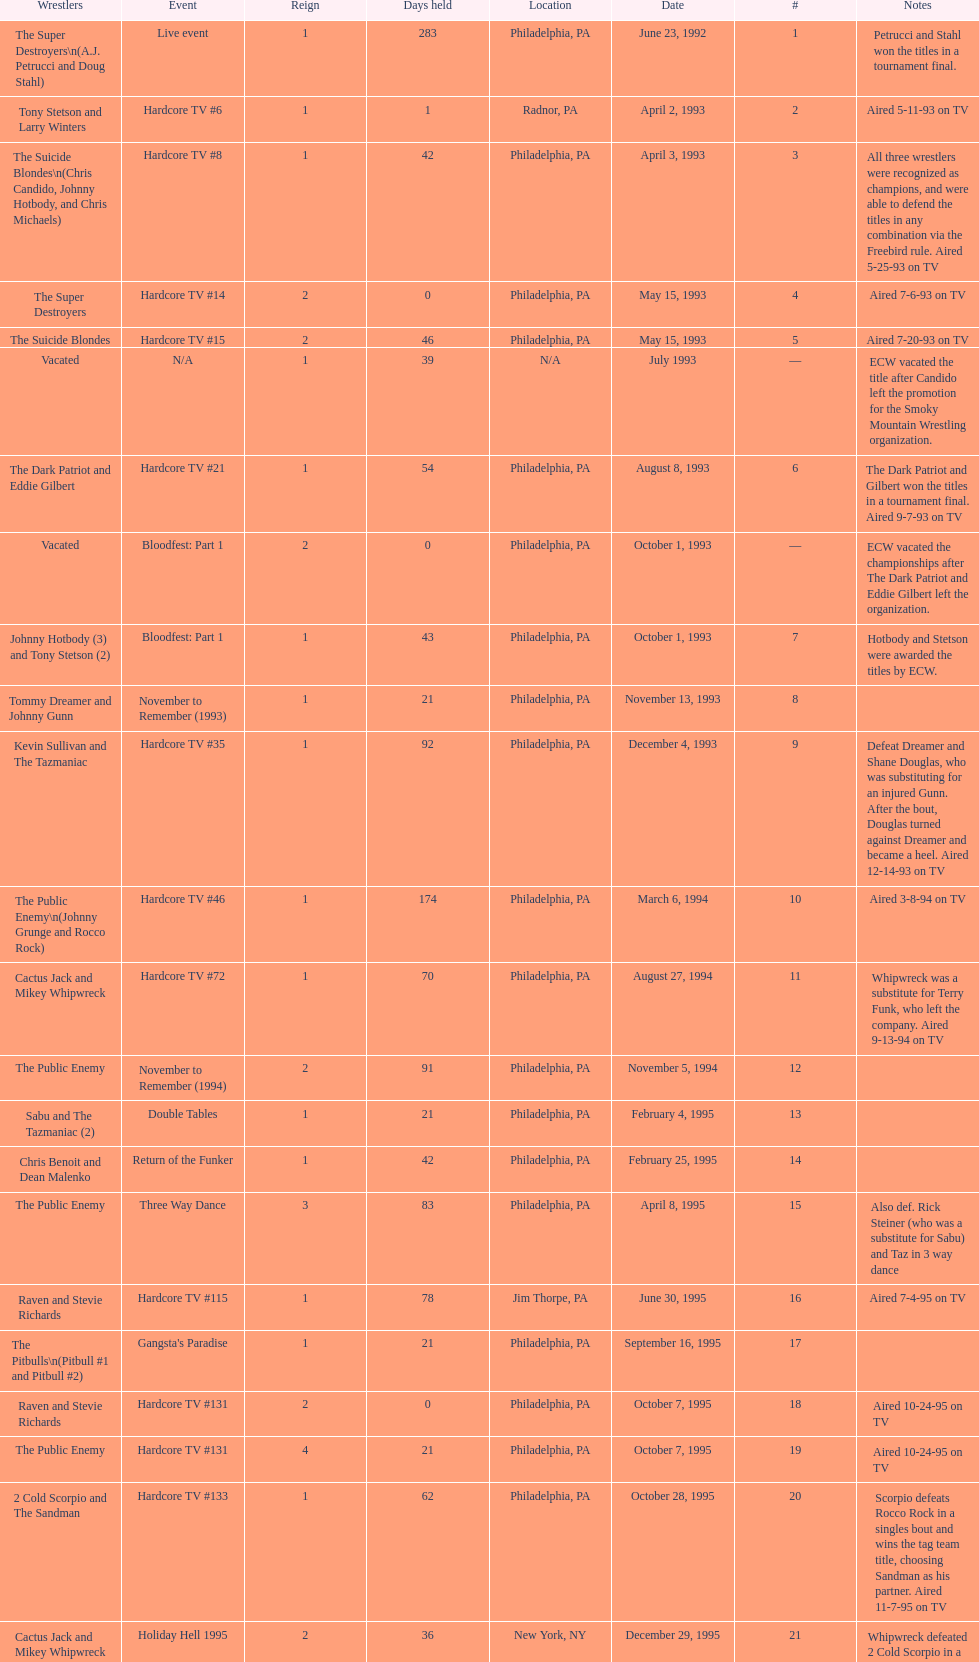Could you help me parse every detail presented in this table? {'header': ['Wrestlers', 'Event', 'Reign', 'Days held', 'Location', 'Date', '#', 'Notes'], 'rows': [['The Super Destroyers\\n(A.J. Petrucci and Doug Stahl)', 'Live event', '1', '283', 'Philadelphia, PA', 'June 23, 1992', '1', 'Petrucci and Stahl won the titles in a tournament final.'], ['Tony Stetson and Larry Winters', 'Hardcore TV #6', '1', '1', 'Radnor, PA', 'April 2, 1993', '2', 'Aired 5-11-93 on TV'], ['The Suicide Blondes\\n(Chris Candido, Johnny Hotbody, and Chris Michaels)', 'Hardcore TV #8', '1', '42', 'Philadelphia, PA', 'April 3, 1993', '3', 'All three wrestlers were recognized as champions, and were able to defend the titles in any combination via the Freebird rule. Aired 5-25-93 on TV'], ['The Super Destroyers', 'Hardcore TV #14', '2', '0', 'Philadelphia, PA', 'May 15, 1993', '4', 'Aired 7-6-93 on TV'], ['The Suicide Blondes', 'Hardcore TV #15', '2', '46', 'Philadelphia, PA', 'May 15, 1993', '5', 'Aired 7-20-93 on TV'], ['Vacated', 'N/A', '1', '39', 'N/A', 'July 1993', '—', 'ECW vacated the title after Candido left the promotion for the Smoky Mountain Wrestling organization.'], ['The Dark Patriot and Eddie Gilbert', 'Hardcore TV #21', '1', '54', 'Philadelphia, PA', 'August 8, 1993', '6', 'The Dark Patriot and Gilbert won the titles in a tournament final. Aired 9-7-93 on TV'], ['Vacated', 'Bloodfest: Part 1', '2', '0', 'Philadelphia, PA', 'October 1, 1993', '—', 'ECW vacated the championships after The Dark Patriot and Eddie Gilbert left the organization.'], ['Johnny Hotbody (3) and Tony Stetson (2)', 'Bloodfest: Part 1', '1', '43', 'Philadelphia, PA', 'October 1, 1993', '7', 'Hotbody and Stetson were awarded the titles by ECW.'], ['Tommy Dreamer and Johnny Gunn', 'November to Remember (1993)', '1', '21', 'Philadelphia, PA', 'November 13, 1993', '8', ''], ['Kevin Sullivan and The Tazmaniac', 'Hardcore TV #35', '1', '92', 'Philadelphia, PA', 'December 4, 1993', '9', 'Defeat Dreamer and Shane Douglas, who was substituting for an injured Gunn. After the bout, Douglas turned against Dreamer and became a heel. Aired 12-14-93 on TV'], ['The Public Enemy\\n(Johnny Grunge and Rocco Rock)', 'Hardcore TV #46', '1', '174', 'Philadelphia, PA', 'March 6, 1994', '10', 'Aired 3-8-94 on TV'], ['Cactus Jack and Mikey Whipwreck', 'Hardcore TV #72', '1', '70', 'Philadelphia, PA', 'August 27, 1994', '11', 'Whipwreck was a substitute for Terry Funk, who left the company. Aired 9-13-94 on TV'], ['The Public Enemy', 'November to Remember (1994)', '2', '91', 'Philadelphia, PA', 'November 5, 1994', '12', ''], ['Sabu and The Tazmaniac (2)', 'Double Tables', '1', '21', 'Philadelphia, PA', 'February 4, 1995', '13', ''], ['Chris Benoit and Dean Malenko', 'Return of the Funker', '1', '42', 'Philadelphia, PA', 'February 25, 1995', '14', ''], ['The Public Enemy', 'Three Way Dance', '3', '83', 'Philadelphia, PA', 'April 8, 1995', '15', 'Also def. Rick Steiner (who was a substitute for Sabu) and Taz in 3 way dance'], ['Raven and Stevie Richards', 'Hardcore TV #115', '1', '78', 'Jim Thorpe, PA', 'June 30, 1995', '16', 'Aired 7-4-95 on TV'], ['The Pitbulls\\n(Pitbull #1 and Pitbull #2)', "Gangsta's Paradise", '1', '21', 'Philadelphia, PA', 'September 16, 1995', '17', ''], ['Raven and Stevie Richards', 'Hardcore TV #131', '2', '0', 'Philadelphia, PA', 'October 7, 1995', '18', 'Aired 10-24-95 on TV'], ['The Public Enemy', 'Hardcore TV #131', '4', '21', 'Philadelphia, PA', 'October 7, 1995', '19', 'Aired 10-24-95 on TV'], ['2 Cold Scorpio and The Sandman', 'Hardcore TV #133', '1', '62', 'Philadelphia, PA', 'October 28, 1995', '20', 'Scorpio defeats Rocco Rock in a singles bout and wins the tag team title, choosing Sandman as his partner. Aired 11-7-95 on TV'], ['Cactus Jack and Mikey Whipwreck', 'Holiday Hell 1995', '2', '36', 'New York, NY', 'December 29, 1995', '21', "Whipwreck defeated 2 Cold Scorpio in a singles match to win both the tag team titles and the ECW World Television Championship; Cactus Jack came out and declared himself to be Mikey's partner after he won the match."], ['The Eliminators\\n(Kronus and Saturn)', 'Big Apple Blizzard Blast', '1', '182', 'New York, NY', 'February 3, 1996', '22', ''], ['The Gangstas\\n(Mustapha Saed and New Jack)', 'Doctor Is In', '1', '139', 'Philadelphia, PA', 'August 3, 1996', '23', ''], ['The Eliminators', 'Hardcore TV #193', '2', '85', 'Middletown, NY', 'December 20, 1996', '24', 'Aired on 12/31/96 on Hardcore TV'], ['The Dudley Boyz\\n(Buh Buh Ray Dudley and D-Von Dudley)', 'Hostile City Showdown', '1', '29', 'Philadelphia, PA', 'March 15, 1997', '25', 'Aired 3/20/97 on Hardcore TV'], ['The Eliminators', 'Barely Legal', '3', '68', 'Philadelphia, PA', 'April 13, 1997', '26', ''], ['The Dudley Boyz', 'Hardcore TV #218', '2', '29', 'Waltham, MA', 'June 20, 1997', '27', 'The Dudley Boyz defeated Kronus in a handicap match as a result of a sidelining injury sustained by Saturn. Aired 6-26-97 on TV'], ['The Gangstas', 'Heat Wave 1997/Hardcore TV #222', '2', '29', 'Philadelphia, PA', 'July 19, 1997', '28', 'Aired 7-24-97 on TV'], ['The Dudley Boyz', 'Hardcore Heaven (1997)', '3', '95', 'Fort Lauderdale, FL', 'August 17, 1997', '29', 'The Dudley Boyz won the championship via forfeit as a result of Mustapha Saed leaving the promotion before Hardcore Heaven took place.'], ['The Gangstanators\\n(Kronus (4) and New Jack (3))', 'As Good as it Gets', '1', '28', 'Philadelphia, PA', 'September 20, 1997', '30', 'Aired 9-27-97 on TV'], ['Full Blooded Italians\\n(Little Guido and Tracy Smothers)', 'Hardcore TV #236', '1', '48', 'Philadelphia, PA', 'October 18, 1997', '31', 'Aired 11-1-97 on TV'], ['Doug Furnas and Phil LaFon', 'Live event', '1', '1', 'Waltham, MA', 'December 5, 1997', '32', ''], ['Chris Candido (3) and Lance Storm', 'Better than Ever', '1', '203', 'Philadelphia, PA', 'December 6, 1997', '33', ''], ['Sabu (2) and Rob Van Dam', 'Hardcore TV #271', '1', '119', 'Philadelphia, PA', 'June 27, 1998', '34', 'Aired 7-1-98 on TV'], ['The Dudley Boyz', 'Hardcore TV #288', '4', '8', 'Cleveland, OH', 'October 24, 1998', '35', 'Aired 10-28-98 on TV'], ['Balls Mahoney and Masato Tanaka', 'November to Remember (1998)', '1', '5', 'New Orleans, LA', 'November 1, 1998', '36', ''], ['The Dudley Boyz', 'Hardcore TV #290', '5', '37', 'New York, NY', 'November 6, 1998', '37', 'Aired 11-11-98 on TV'], ['Sabu (3) and Rob Van Dam', 'ECW/FMW Supershow II', '2', '125', 'Tokyo, Japan', 'December 13, 1998', '38', 'Aired 12-16-98 on TV'], ['The Dudley Boyz', 'Hardcore TV #313', '6', '92', 'Buffalo, NY', 'April 17, 1999', '39', 'D-Von Dudley defeated Van Dam in a singles match to win the championship for his team. Aired 4-23-99 on TV'], ['Spike Dudley and Balls Mahoney (2)', 'Heat Wave (1999)', '1', '26', 'Dayton, OH', 'July 18, 1999', '40', ''], ['The Dudley Boyz', 'Hardcore TV #330', '7', '1', 'Cleveland, OH', 'August 13, 1999', '41', 'Aired 8-20-99 on TV'], ['Spike Dudley and Balls Mahoney (3)', 'Hardcore TV #331', '2', '12', 'Toledo, OH', 'August 14, 1999', '42', 'Aired 8-27-99 on TV'], ['The Dudley Boyz', 'ECW on TNN#2', '8', '0', 'New York, NY', 'August 26, 1999', '43', 'Aired 9-3-99 on TV'], ['Tommy Dreamer (2) and Raven (3)', 'ECW on TNN#2', '1', '136', 'New York, NY', 'August 26, 1999', '44', 'Aired 9-3-99 on TV'], ['Impact Players\\n(Justin Credible and Lance Storm (2))', 'Guilty as Charged (2000)', '1', '48', 'Birmingham, AL', 'January 9, 2000', '45', ''], ['Tommy Dreamer (3) and Masato Tanaka (2)', 'Hardcore TV #358', '1', '7', 'Cincinnati, OH', 'February 26, 2000', '46', 'Aired 3-7-00 on TV'], ['Mike Awesome and Raven (4)', 'ECW on TNN#29', '1', '8', 'Philadelphia, PA', 'March 4, 2000', '47', 'Aired 3-10-00 on TV'], ['Impact Players\\n(Justin Credible and Lance Storm (3))', 'Living Dangerously', '2', '31', 'Danbury, CT', 'March 12, 2000', '48', ''], ['Vacated', 'Live event', '3', '125', 'Philadelphia, PA', 'April 22, 2000', '—', 'At CyberSlam, Justin Credible threw down the titles to become eligible for the ECW World Heavyweight Championship. Storm later left for World Championship Wrestling. As a result of the circumstances, Credible vacated the championship.'], ['Yoshihiro Tajiri and Mikey Whipwreck (3)', 'ECW on TNN#55', '1', '1', 'New York, NY', 'August 25, 2000', '49', 'Aired 9-1-00 on TV'], ['Full Blooded Italians\\n(Little Guido (2) and Tony Mamaluke)', 'ECW on TNN#56', '1', '99', 'New York, NY', 'August 26, 2000', '50', 'Aired 9-8-00 on TV'], ['Danny Doring and Roadkill', 'Massacre on 34th Street', '1', '122', 'New York, NY', 'December 3, 2000', '51', "Doring and Roadkill's reign was the final one in the title's history."]]} What is the next event after hardcore tv #15? Hardcore TV #21. 